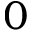<formula> <loc_0><loc_0><loc_500><loc_500>0</formula> 